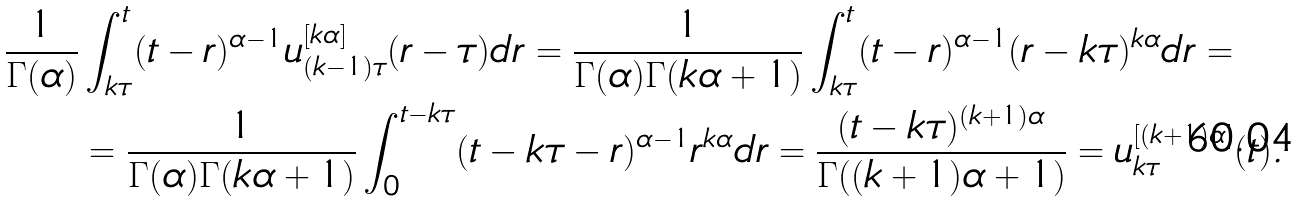<formula> <loc_0><loc_0><loc_500><loc_500>\frac { 1 } { \Gamma ( \alpha ) } & \int _ { k \tau } ^ { t } ( t - r ) ^ { \alpha - 1 } u _ { ( k - 1 ) \tau } ^ { [ k \alpha ] } ( r - \tau ) d r = \frac { 1 } { \Gamma ( \alpha ) \Gamma ( k \alpha + 1 ) } \int _ { k \tau } ^ { t } ( t - r ) ^ { \alpha - 1 } ( r - k \tau ) ^ { k \alpha } d r = \\ & = \frac { 1 } { \Gamma ( \alpha ) \Gamma ( k \alpha + 1 ) } \int _ { 0 } ^ { t - k \tau } ( t - k \tau - r ) ^ { \alpha - 1 } r ^ { k \alpha } d r = \frac { ( t - k \tau ) ^ { ( k + 1 ) \alpha } } { \Gamma ( ( k + 1 ) \alpha + 1 ) } = u _ { k \tau } ^ { [ ( k + 1 ) \alpha ] } ( t ) .</formula> 